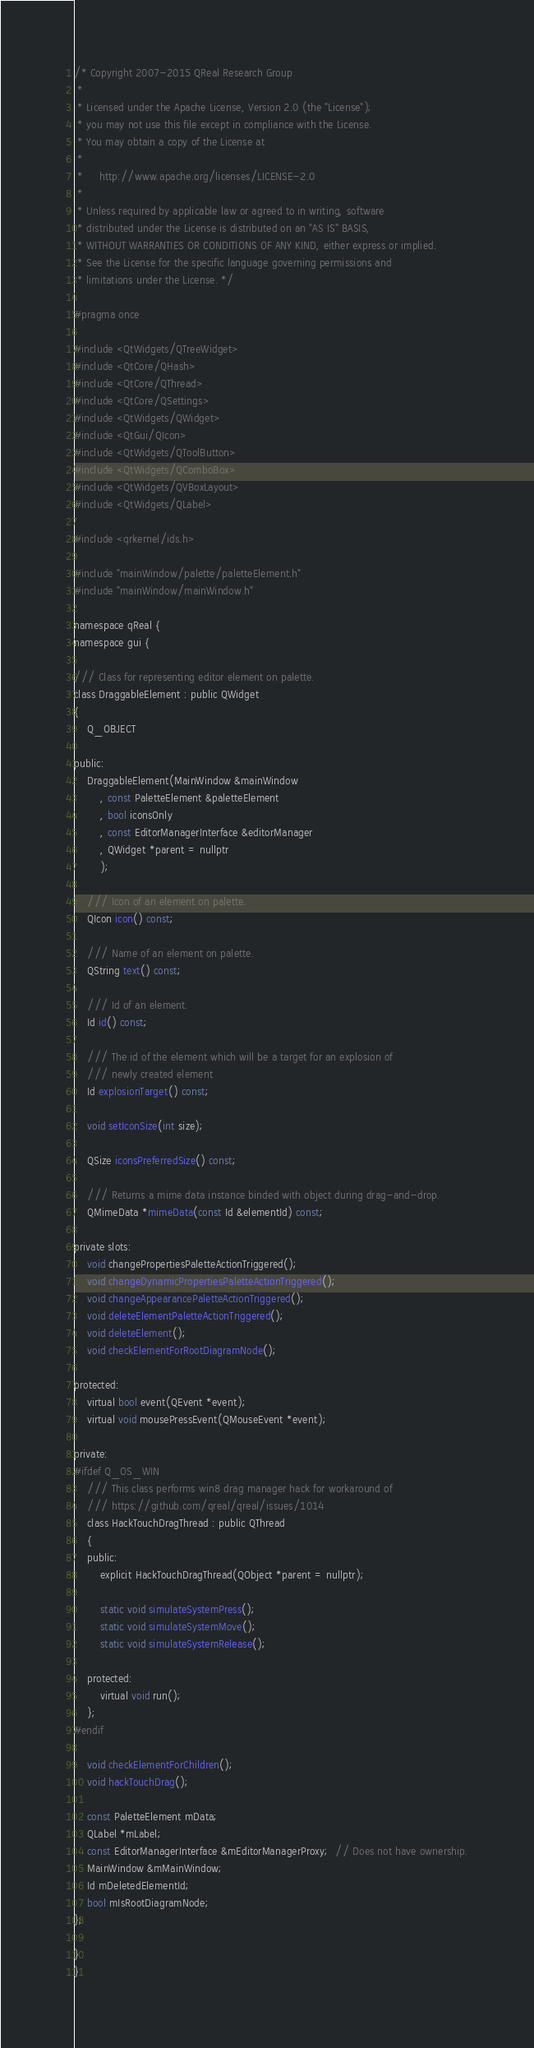<code> <loc_0><loc_0><loc_500><loc_500><_C_>/* Copyright 2007-2015 QReal Research Group
 *
 * Licensed under the Apache License, Version 2.0 (the "License");
 * you may not use this file except in compliance with the License.
 * You may obtain a copy of the License at
 *
 *     http://www.apache.org/licenses/LICENSE-2.0
 *
 * Unless required by applicable law or agreed to in writing, software
 * distributed under the License is distributed on an "AS IS" BASIS,
 * WITHOUT WARRANTIES OR CONDITIONS OF ANY KIND, either express or implied.
 * See the License for the specific language governing permissions and
 * limitations under the License. */

#pragma once

#include <QtWidgets/QTreeWidget>
#include <QtCore/QHash>
#include <QtCore/QThread>
#include <QtCore/QSettings>
#include <QtWidgets/QWidget>
#include <QtGui/QIcon>
#include <QtWidgets/QToolButton>
#include <QtWidgets/QComboBox>
#include <QtWidgets/QVBoxLayout>
#include <QtWidgets/QLabel>

#include <qrkernel/ids.h>

#include "mainWindow/palette/paletteElement.h"
#include "mainWindow/mainWindow.h"

namespace qReal {
namespace gui {

/// Class for representing editor element on palette.
class DraggableElement : public QWidget
{
	Q_OBJECT

public:
	DraggableElement(MainWindow &mainWindow
		, const PaletteElement &paletteElement
		, bool iconsOnly
		, const EditorManagerInterface &editorManager
		, QWidget *parent = nullptr
		);

	/// Icon of an element on palette.
	QIcon icon() const;

	/// Name of an element on palette.
	QString text() const;

	/// Id of an element.
	Id id() const;

	/// The id of the element which will be a target for an explosion of
	/// newly created element
	Id explosionTarget() const;

	void setIconSize(int size);

	QSize iconsPreferredSize() const;

	/// Returns a mime data instance binded with object during drag-and-drop.
	QMimeData *mimeData(const Id &elementId) const;

private slots:
	void changePropertiesPaletteActionTriggered();
	void changeDynamicPropertiesPaletteActionTriggered();
	void changeAppearancePaletteActionTriggered();
	void deleteElementPaletteActionTriggered();
	void deleteElement();
	void checkElementForRootDiagramNode();

protected:
	virtual bool event(QEvent *event);
	virtual void mousePressEvent(QMouseEvent *event);

private:
#ifdef Q_OS_WIN
	/// This class performs win8 drag manager hack for workaround of
	/// https://github.com/qreal/qreal/issues/1014
	class HackTouchDragThread : public QThread
	{
	public:
		explicit HackTouchDragThread(QObject *parent = nullptr);

		static void simulateSystemPress();
		static void simulateSystemMove();
		static void simulateSystemRelease();

	protected:
		virtual void run();
	};
#endif

	void checkElementForChildren();
	void hackTouchDrag();

	const PaletteElement mData;
	QLabel *mLabel;
	const EditorManagerInterface &mEditorManagerProxy;  // Does not have ownership.
	MainWindow &mMainWindow;
	Id mDeletedElementId;
	bool mIsRootDiagramNode;
};

}
}
</code> 